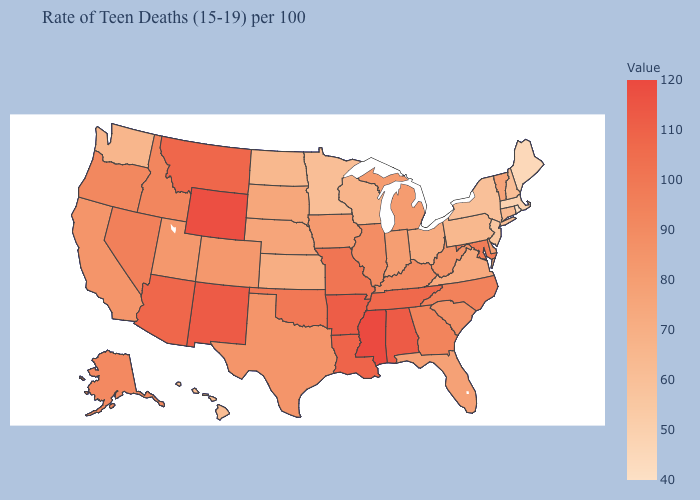Does Alabama have a higher value than West Virginia?
Keep it brief. Yes. Which states hav the highest value in the Northeast?
Give a very brief answer. Vermont. Is the legend a continuous bar?
Short answer required. Yes. Which states have the lowest value in the MidWest?
Be succinct. Minnesota. Which states have the lowest value in the USA?
Concise answer only. Rhode Island. Does Indiana have the lowest value in the USA?
Answer briefly. No. Does Rhode Island have the lowest value in the USA?
Answer briefly. Yes. Does Wyoming have the highest value in the West?
Answer briefly. Yes. 